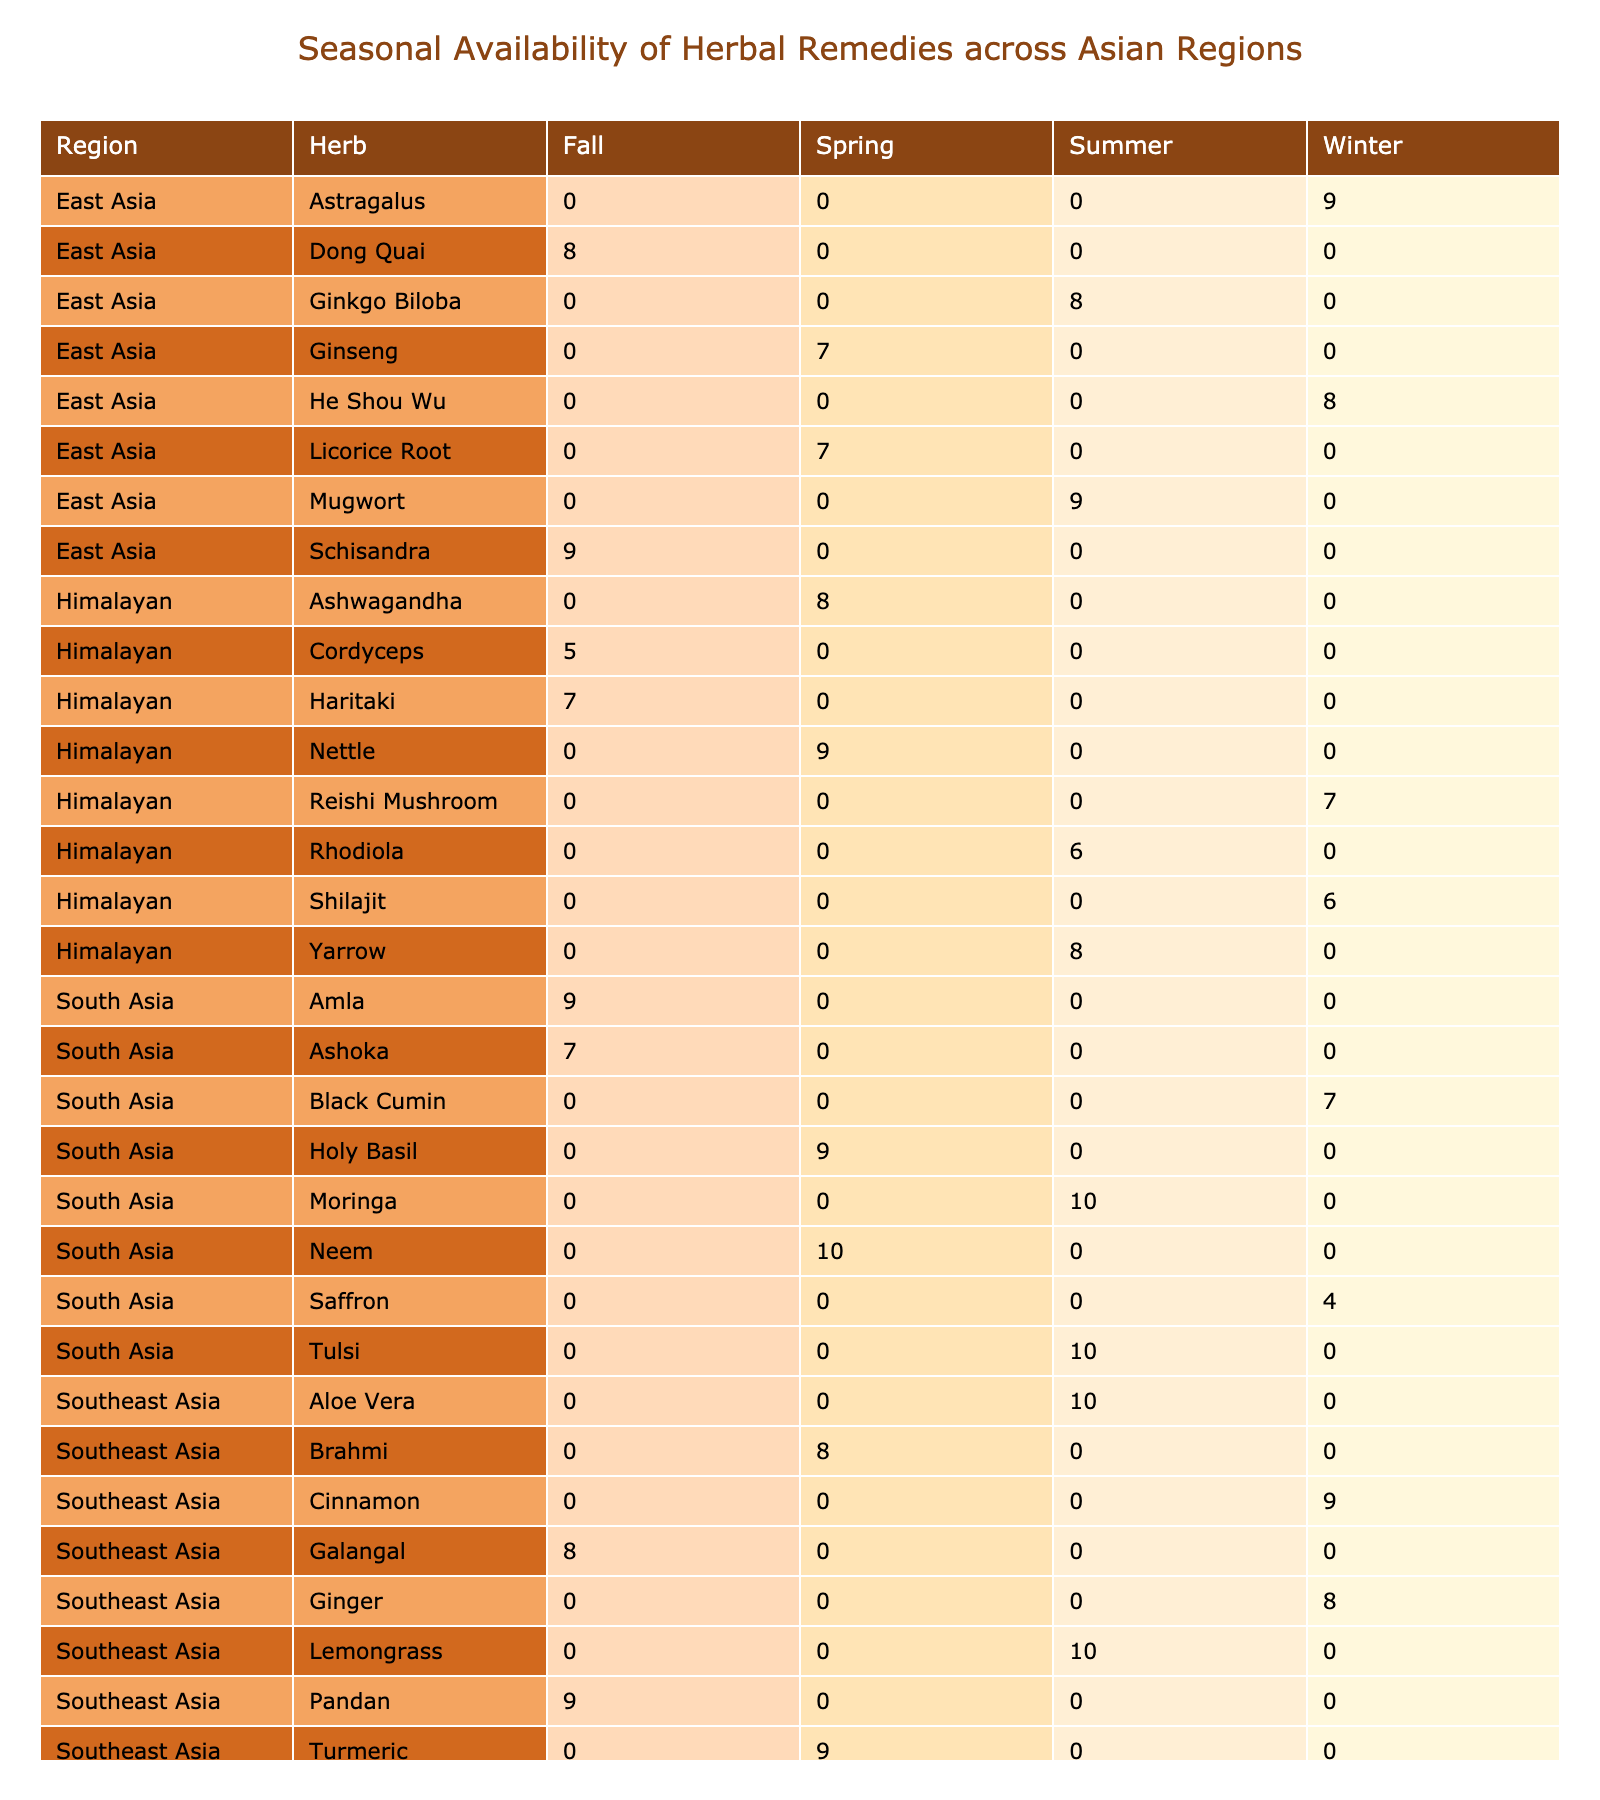What is the highest availability of herbs in the Spring season? In the Spring season, the herbs and their availability scores are: Ashwagandha (8), Turmeric (9), Ginseng (7), Holy Basil (9), Nettle (9), Brahmi (8), Licorice Root (7), and Neem (10). The highest availability score is for Neem, which has a score of 10.
Answer: Neem Which herb has the lowest availability in the Fall season? In the Fall season, the herbs and their availability scores are: Cordyceps (5), Galangal (8), Schisandra (9), and Amla (9). Among these, Cordyceps has the lowest availability score of 5.
Answer: Cordyceps What is the average availability of herbs in the Winter season across all regions? The availability scores for Winter season herbs are: Reishi Mushroom (7), Ginger (8), Astragalus (9), Saffron (4), Shilajit (6), Cinnamon (9), He Shou Wu (8), and Black Cumin (7). To find the average, we sum these values: 7 + 8 + 9 + 4 + 6 + 9 + 8 + 7 = 58, and divide by the number of herbs, which is 8. Therefore, the average is 58 / 8 = 7.25.
Answer: 7.25 Is there a herb that is available in all four seasons? By checking the availability scores across all seasons for each herb, we see that no herb is listed in every season. Therefore, the answer is no, there is no herb available in all four seasons.
Answer: No Which region has the highest average availability of herbs in the Summer season? In the Summer season, the herbs and their availability scores are: Rhodiola (6), Lemongrass (10), Ginkgo Biloba (8), Moringa (10), Yarrow (8), Aloe Vera (10), Mugwort (9), and Tulsi (10). The average availability for each region is calculated as follows: Himalayan: (6) / 1 = 6, Southeast Asia: (10 + 10) / 2 = 10, East Asia: (8 + 9) / 2 = 8.5, South Asia: (10 + 10) / 2 = 10. The highest averages are in Southeast Asia and South Asia, both with a score of 10.
Answer: Southeast Asia & South Asia What is the total availability score of Turmeric in all seasons? Turmeric is listed only in the Spring season with an availability score of 9. Therefore, the total availability score of Turmeric in all seasons is simply 9.
Answer: 9 